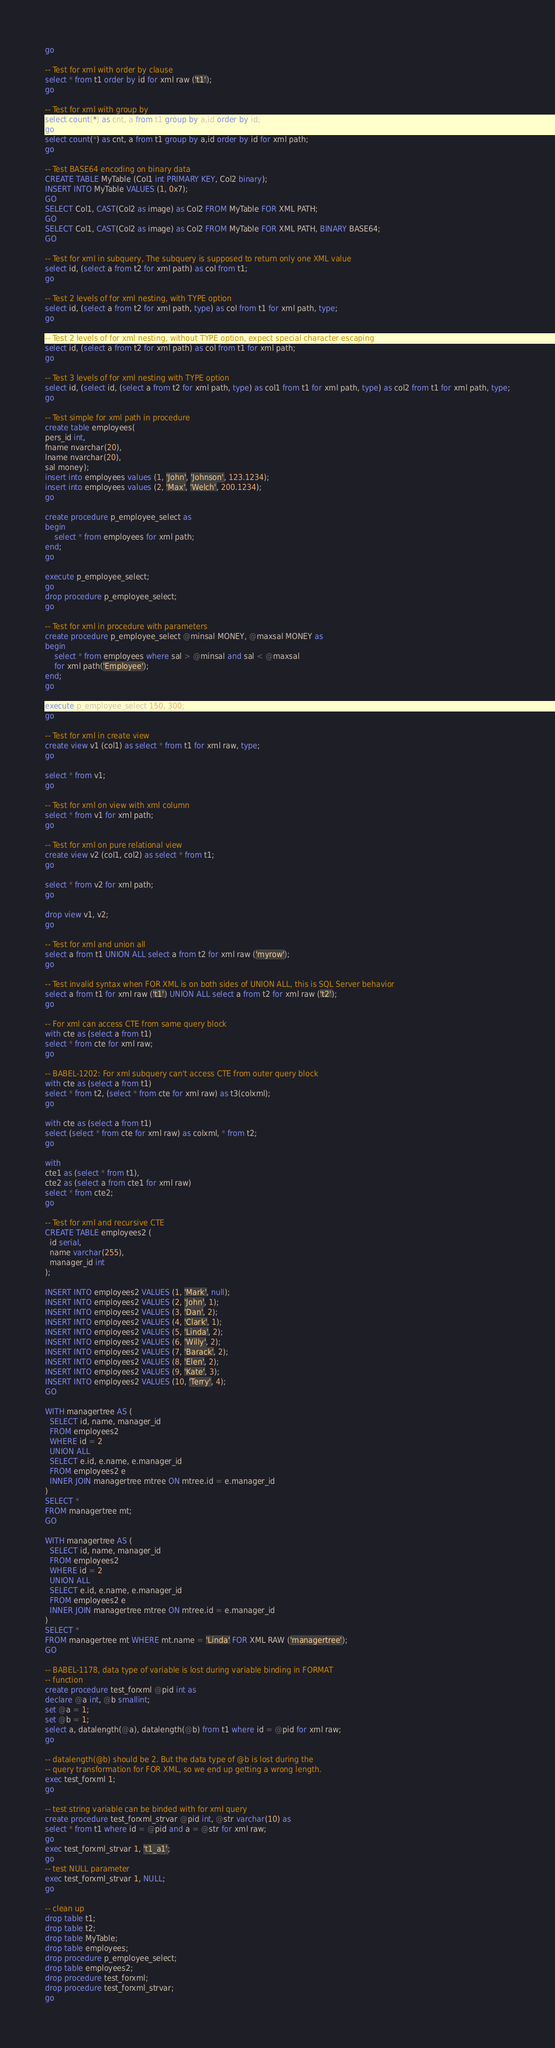<code> <loc_0><loc_0><loc_500><loc_500><_SQL_>go

-- Test for xml with order by clause
select * from t1 order by id for xml raw ('t1');
go

-- Test for xml with group by
select count(*) as cnt, a from t1 group by a,id order by id;
go
select count(*) as cnt, a from t1 group by a,id order by id for xml path;
go

-- Test BASE64 encoding on binary data
CREATE TABLE MyTable (Col1 int PRIMARY KEY, Col2 binary);
INSERT INTO MyTable VALUES (1, 0x7);
GO
SELECT Col1, CAST(Col2 as image) as Col2 FROM MyTable FOR XML PATH;
GO
SELECT Col1, CAST(Col2 as image) as Col2 FROM MyTable FOR XML PATH, BINARY BASE64;
GO

-- Test for xml in subquery, The subquery is supposed to return only one XML value
select id, (select a from t2 for xml path) as col from t1;
go

-- Test 2 levels of for xml nesting, with TYPE option
select id, (select a from t2 for xml path, type) as col from t1 for xml path, type;
go

-- Test 2 levels of for xml nesting, without TYPE option, expect special character escaping
select id, (select a from t2 for xml path) as col from t1 for xml path;
go

-- Test 3 levels of for xml nesting with TYPE option
select id, (select id, (select a from t2 for xml path, type) as col1 from t1 for xml path, type) as col2 from t1 for xml path, type;
go

-- Test simple for xml path in procedure
create table employees(
pers_id int,
fname nvarchar(20),
lname nvarchar(20),
sal money);
insert into employees values (1, 'John', 'Johnson', 123.1234);
insert into employees values (2, 'Max', 'Welch', 200.1234);
go

create procedure p_employee_select as
begin
	select * from employees for xml path;
end;
go

execute p_employee_select;
go
drop procedure p_employee_select;
go

-- Test for xml in procedure with parameters
create procedure p_employee_select @minsal MONEY, @maxsal MONEY as
begin
	select * from employees where sal > @minsal and sal < @maxsal
	for xml path('Employee');
end;
go

execute p_employee_select 150, 300;
go

-- Test for xml in create view
create view v1 (col1) as select * from t1 for xml raw, type;
go

select * from v1;
go

-- Test for xml on view with xml column
select * from v1 for xml path;
go

-- Test for xml on pure relational view
create view v2 (col1, col2) as select * from t1;
go

select * from v2 for xml path;
go

drop view v1, v2;
go

-- Test for xml and union all
select a from t1 UNION ALL select a from t2 for xml raw ('myrow');
go

-- Test invalid syntax when FOR XML is on both sides of UNION ALL, this is SQL Server behavior
select a from t1 for xml raw ('t1') UNION ALL select a from t2 for xml raw ('t2');
go

-- For xml can access CTE from same query block
with cte as (select a from t1)
select * from cte for xml raw;
go

-- BABEL-1202: For xml subquery can't access CTE from outer query block
with cte as (select a from t1)
select * from t2, (select * from cte for xml raw) as t3(colxml);
go

with cte as (select a from t1)
select (select * from cte for xml raw) as colxml, * from t2;
go

with
cte1 as (select * from t1),
cte2 as (select a from cte1 for xml raw)
select * from cte2;
go

-- Test for xml and recursive CTE
CREATE TABLE employees2 (
  id serial,
  name varchar(255),
  manager_id int
);

INSERT INTO employees2 VALUES (1, 'Mark', null);
INSERT INTO employees2 VALUES (2, 'John', 1);
INSERT INTO employees2 VALUES (3, 'Dan', 2);
INSERT INTO employees2 VALUES (4, 'Clark', 1);
INSERT INTO employees2 VALUES (5, 'Linda', 2);
INSERT INTO employees2 VALUES (6, 'Willy', 2);
INSERT INTO employees2 VALUES (7, 'Barack', 2);
INSERT INTO employees2 VALUES (8, 'Elen', 2);
INSERT INTO employees2 VALUES (9, 'Kate', 3);
INSERT INTO employees2 VALUES (10, 'Terry', 4);
GO

WITH managertree AS (
  SELECT id, name, manager_id
  FROM employees2
  WHERE id = 2
  UNION ALL
  SELECT e.id, e.name, e.manager_id
  FROM employees2 e
  INNER JOIN managertree mtree ON mtree.id = e.manager_id
)
SELECT *
FROM managertree mt;
GO

WITH managertree AS (
  SELECT id, name, manager_id
  FROM employees2
  WHERE id = 2
  UNION ALL
  SELECT e.id, e.name, e.manager_id
  FROM employees2 e
  INNER JOIN managertree mtree ON mtree.id = e.manager_id
)
SELECT *
FROM managertree mt WHERE mt.name = 'Linda' FOR XML RAW ('managertree');
GO

-- BABEL-1178, data type of variable is lost during variable binding in FORMAT
-- function
create procedure test_forxml @pid int as
declare @a int, @b smallint;
set @a = 1;
set @b = 1;
select a, datalength(@a), datalength(@b) from t1 where id = @pid for xml raw;
go

-- datalength(@b) should be 2. But the data type of @b is lost during the
-- query transformation for FOR XML, so we end up getting a wrong length.
exec test_forxml 1;
go

-- test string variable can be binded with for xml query
create procedure test_forxml_strvar @pid int, @str varchar(10) as
select * from t1 where id = @pid and a = @str for xml raw;
go
exec test_forxml_strvar 1, 't1_a1';
go
-- test NULL parameter
exec test_forxml_strvar 1, NULL;
go

-- clean up
drop table t1;
drop table t2;
drop table MyTable;
drop table employees;
drop procedure p_employee_select;
drop table employees2;
drop procedure test_forxml;
drop procedure test_forxml_strvar;
go
</code> 